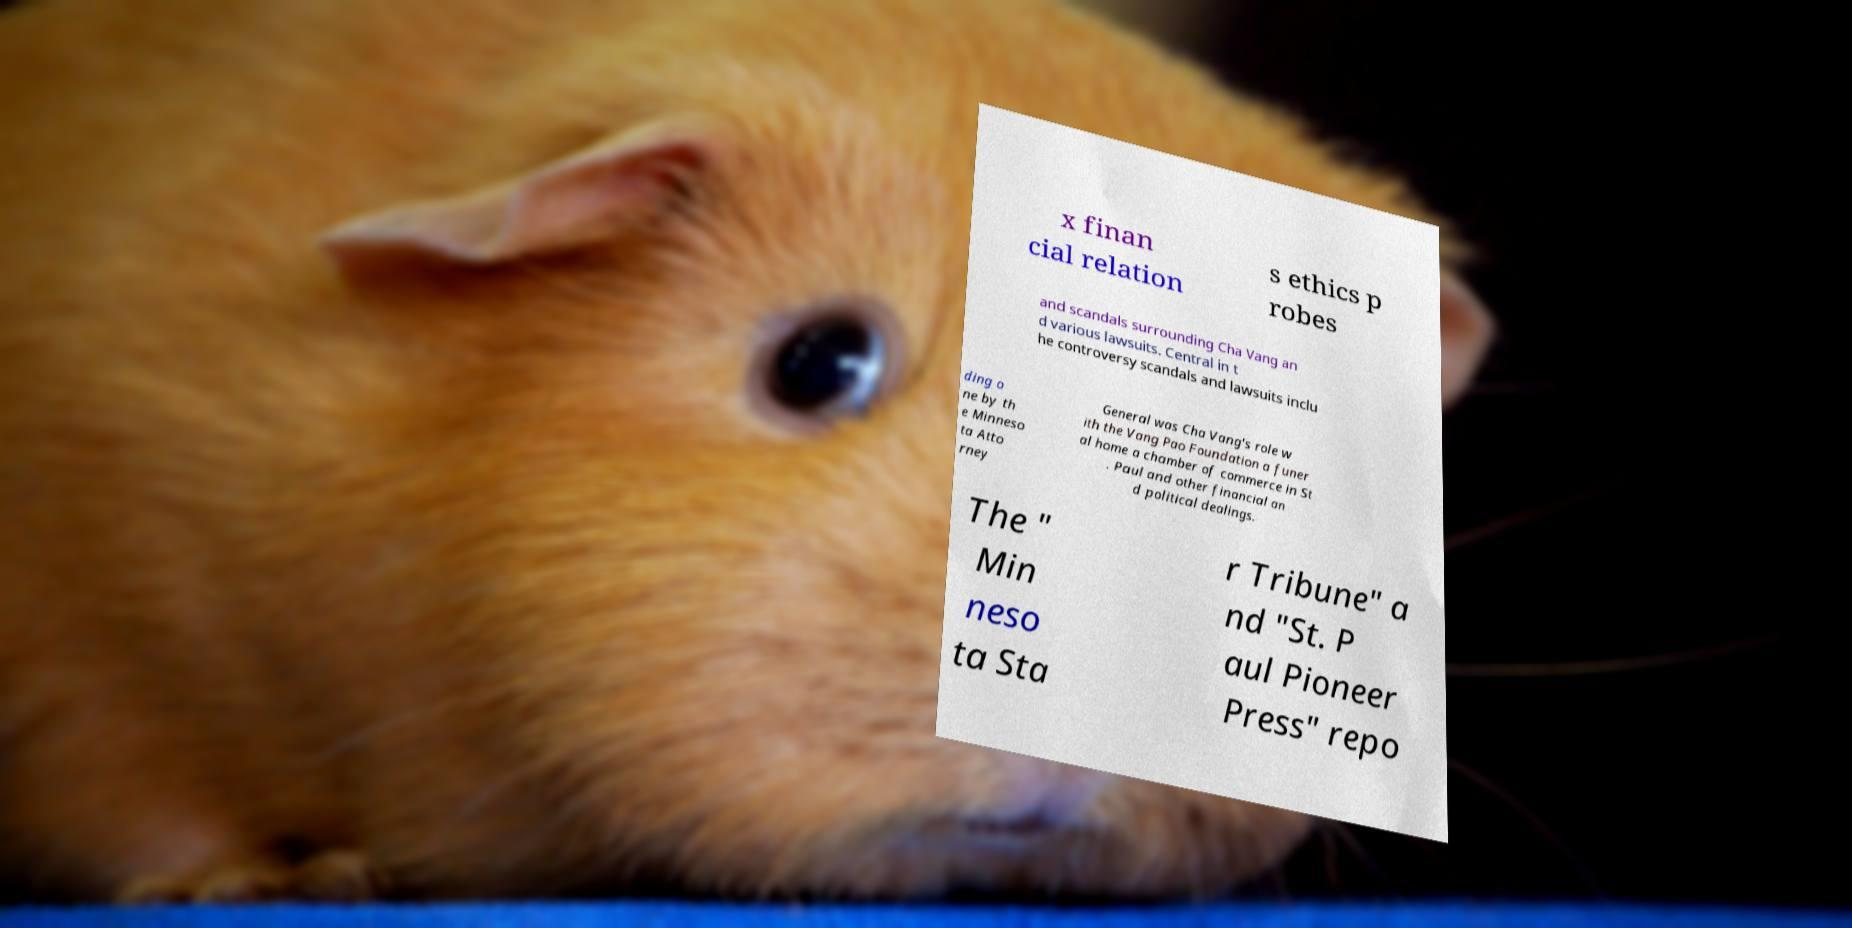Can you read and provide the text displayed in the image?This photo seems to have some interesting text. Can you extract and type it out for me? x finan cial relation s ethics p robes and scandals surrounding Cha Vang an d various lawsuits. Central in t he controversy scandals and lawsuits inclu ding o ne by th e Minneso ta Atto rney General was Cha Vang's role w ith the Vang Pao Foundation a funer al home a chamber of commerce in St . Paul and other financial an d political dealings. The " Min neso ta Sta r Tribune" a nd "St. P aul Pioneer Press" repo 